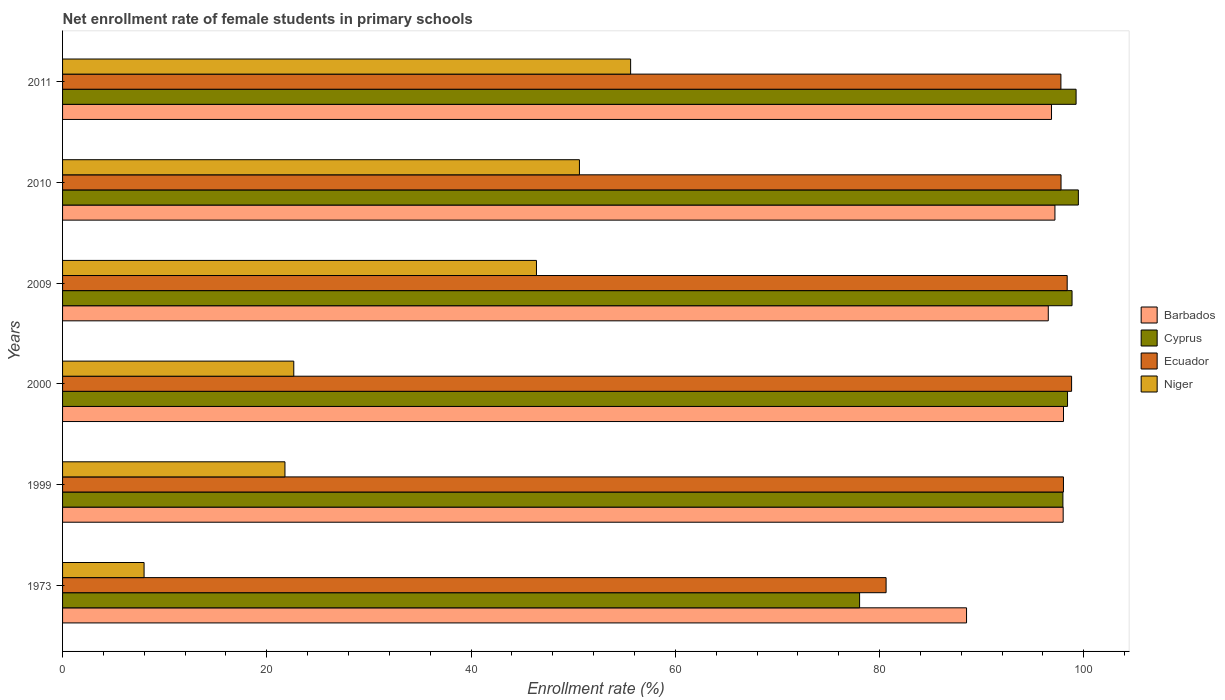How many groups of bars are there?
Keep it short and to the point. 6. Are the number of bars per tick equal to the number of legend labels?
Offer a very short reply. Yes. Are the number of bars on each tick of the Y-axis equal?
Provide a short and direct response. Yes. How many bars are there on the 3rd tick from the bottom?
Provide a succinct answer. 4. What is the label of the 5th group of bars from the top?
Offer a terse response. 1999. What is the net enrollment rate of female students in primary schools in Barbados in 2009?
Your response must be concise. 96.52. Across all years, what is the maximum net enrollment rate of female students in primary schools in Niger?
Your answer should be compact. 55.62. Across all years, what is the minimum net enrollment rate of female students in primary schools in Cyprus?
Your response must be concise. 78.04. In which year was the net enrollment rate of female students in primary schools in Niger maximum?
Make the answer very short. 2011. In which year was the net enrollment rate of female students in primary schools in Niger minimum?
Provide a short and direct response. 1973. What is the total net enrollment rate of female students in primary schools in Ecuador in the graph?
Your answer should be very brief. 571.34. What is the difference between the net enrollment rate of female students in primary schools in Barbados in 1999 and that in 2009?
Offer a very short reply. 1.46. What is the difference between the net enrollment rate of female students in primary schools in Niger in 2000 and the net enrollment rate of female students in primary schools in Ecuador in 1999?
Give a very brief answer. -75.37. What is the average net enrollment rate of female students in primary schools in Cyprus per year?
Make the answer very short. 95.33. In the year 2010, what is the difference between the net enrollment rate of female students in primary schools in Cyprus and net enrollment rate of female students in primary schools in Barbados?
Keep it short and to the point. 2.29. In how many years, is the net enrollment rate of female students in primary schools in Barbados greater than 96 %?
Your response must be concise. 5. What is the ratio of the net enrollment rate of female students in primary schools in Niger in 1999 to that in 2010?
Your answer should be compact. 0.43. What is the difference between the highest and the second highest net enrollment rate of female students in primary schools in Ecuador?
Keep it short and to the point. 0.43. What is the difference between the highest and the lowest net enrollment rate of female students in primary schools in Niger?
Your response must be concise. 47.64. In how many years, is the net enrollment rate of female students in primary schools in Barbados greater than the average net enrollment rate of female students in primary schools in Barbados taken over all years?
Your answer should be compact. 5. Is the sum of the net enrollment rate of female students in primary schools in Cyprus in 1999 and 2011 greater than the maximum net enrollment rate of female students in primary schools in Ecuador across all years?
Your answer should be compact. Yes. Is it the case that in every year, the sum of the net enrollment rate of female students in primary schools in Barbados and net enrollment rate of female students in primary schools in Ecuador is greater than the sum of net enrollment rate of female students in primary schools in Niger and net enrollment rate of female students in primary schools in Cyprus?
Give a very brief answer. No. What does the 2nd bar from the top in 2009 represents?
Your response must be concise. Ecuador. What does the 1st bar from the bottom in 1999 represents?
Your response must be concise. Barbados. How many bars are there?
Keep it short and to the point. 24. How many years are there in the graph?
Your answer should be very brief. 6. What is the difference between two consecutive major ticks on the X-axis?
Your response must be concise. 20. Are the values on the major ticks of X-axis written in scientific E-notation?
Make the answer very short. No. Where does the legend appear in the graph?
Your answer should be very brief. Center right. How many legend labels are there?
Ensure brevity in your answer.  4. What is the title of the graph?
Make the answer very short. Net enrollment rate of female students in primary schools. Does "Lesotho" appear as one of the legend labels in the graph?
Offer a very short reply. No. What is the label or title of the X-axis?
Your answer should be very brief. Enrollment rate (%). What is the Enrollment rate (%) of Barbados in 1973?
Ensure brevity in your answer.  88.52. What is the Enrollment rate (%) of Cyprus in 1973?
Your answer should be compact. 78.04. What is the Enrollment rate (%) in Ecuador in 1973?
Your answer should be compact. 80.64. What is the Enrollment rate (%) of Niger in 1973?
Your answer should be compact. 7.98. What is the Enrollment rate (%) of Barbados in 1999?
Ensure brevity in your answer.  97.98. What is the Enrollment rate (%) of Cyprus in 1999?
Provide a succinct answer. 97.95. What is the Enrollment rate (%) in Ecuador in 1999?
Your response must be concise. 98.01. What is the Enrollment rate (%) of Niger in 1999?
Your answer should be compact. 21.78. What is the Enrollment rate (%) of Barbados in 2000?
Make the answer very short. 98.01. What is the Enrollment rate (%) of Cyprus in 2000?
Offer a very short reply. 98.4. What is the Enrollment rate (%) of Ecuador in 2000?
Your response must be concise. 98.8. What is the Enrollment rate (%) in Niger in 2000?
Your response must be concise. 22.64. What is the Enrollment rate (%) in Barbados in 2009?
Your answer should be compact. 96.52. What is the Enrollment rate (%) of Cyprus in 2009?
Provide a succinct answer. 98.85. What is the Enrollment rate (%) in Ecuador in 2009?
Give a very brief answer. 98.37. What is the Enrollment rate (%) of Niger in 2009?
Your response must be concise. 46.4. What is the Enrollment rate (%) in Barbados in 2010?
Make the answer very short. 97.17. What is the Enrollment rate (%) of Cyprus in 2010?
Offer a terse response. 99.46. What is the Enrollment rate (%) in Ecuador in 2010?
Your response must be concise. 97.77. What is the Enrollment rate (%) of Niger in 2010?
Give a very brief answer. 50.61. What is the Enrollment rate (%) of Barbados in 2011?
Make the answer very short. 96.84. What is the Enrollment rate (%) of Cyprus in 2011?
Offer a terse response. 99.24. What is the Enrollment rate (%) in Ecuador in 2011?
Offer a very short reply. 97.76. What is the Enrollment rate (%) of Niger in 2011?
Offer a terse response. 55.62. Across all years, what is the maximum Enrollment rate (%) of Barbados?
Provide a succinct answer. 98.01. Across all years, what is the maximum Enrollment rate (%) of Cyprus?
Provide a succinct answer. 99.46. Across all years, what is the maximum Enrollment rate (%) in Ecuador?
Offer a very short reply. 98.8. Across all years, what is the maximum Enrollment rate (%) of Niger?
Offer a terse response. 55.62. Across all years, what is the minimum Enrollment rate (%) in Barbados?
Provide a succinct answer. 88.52. Across all years, what is the minimum Enrollment rate (%) of Cyprus?
Provide a succinct answer. 78.04. Across all years, what is the minimum Enrollment rate (%) of Ecuador?
Offer a terse response. 80.64. Across all years, what is the minimum Enrollment rate (%) of Niger?
Provide a succinct answer. 7.98. What is the total Enrollment rate (%) in Barbados in the graph?
Give a very brief answer. 575.03. What is the total Enrollment rate (%) in Cyprus in the graph?
Make the answer very short. 571.96. What is the total Enrollment rate (%) of Ecuador in the graph?
Provide a succinct answer. 571.34. What is the total Enrollment rate (%) of Niger in the graph?
Provide a succinct answer. 205.04. What is the difference between the Enrollment rate (%) in Barbados in 1973 and that in 1999?
Provide a succinct answer. -9.46. What is the difference between the Enrollment rate (%) of Cyprus in 1973 and that in 1999?
Offer a very short reply. -19.91. What is the difference between the Enrollment rate (%) of Ecuador in 1973 and that in 1999?
Your answer should be very brief. -17.37. What is the difference between the Enrollment rate (%) in Niger in 1973 and that in 1999?
Your answer should be compact. -13.79. What is the difference between the Enrollment rate (%) of Barbados in 1973 and that in 2000?
Make the answer very short. -9.49. What is the difference between the Enrollment rate (%) in Cyprus in 1973 and that in 2000?
Give a very brief answer. -20.36. What is the difference between the Enrollment rate (%) of Ecuador in 1973 and that in 2000?
Provide a succinct answer. -18.16. What is the difference between the Enrollment rate (%) in Niger in 1973 and that in 2000?
Offer a terse response. -14.66. What is the difference between the Enrollment rate (%) in Barbados in 1973 and that in 2009?
Give a very brief answer. -8. What is the difference between the Enrollment rate (%) in Cyprus in 1973 and that in 2009?
Ensure brevity in your answer.  -20.8. What is the difference between the Enrollment rate (%) in Ecuador in 1973 and that in 2009?
Give a very brief answer. -17.73. What is the difference between the Enrollment rate (%) in Niger in 1973 and that in 2009?
Ensure brevity in your answer.  -38.42. What is the difference between the Enrollment rate (%) in Barbados in 1973 and that in 2010?
Offer a very short reply. -8.66. What is the difference between the Enrollment rate (%) in Cyprus in 1973 and that in 2010?
Provide a short and direct response. -21.42. What is the difference between the Enrollment rate (%) of Ecuador in 1973 and that in 2010?
Your response must be concise. -17.13. What is the difference between the Enrollment rate (%) of Niger in 1973 and that in 2010?
Provide a short and direct response. -42.63. What is the difference between the Enrollment rate (%) of Barbados in 1973 and that in 2011?
Provide a succinct answer. -8.32. What is the difference between the Enrollment rate (%) of Cyprus in 1973 and that in 2011?
Your answer should be compact. -21.2. What is the difference between the Enrollment rate (%) in Ecuador in 1973 and that in 2011?
Your answer should be very brief. -17.12. What is the difference between the Enrollment rate (%) in Niger in 1973 and that in 2011?
Provide a short and direct response. -47.64. What is the difference between the Enrollment rate (%) in Barbados in 1999 and that in 2000?
Provide a short and direct response. -0.03. What is the difference between the Enrollment rate (%) in Cyprus in 1999 and that in 2000?
Offer a terse response. -0.45. What is the difference between the Enrollment rate (%) in Ecuador in 1999 and that in 2000?
Provide a succinct answer. -0.8. What is the difference between the Enrollment rate (%) of Niger in 1999 and that in 2000?
Make the answer very short. -0.86. What is the difference between the Enrollment rate (%) in Barbados in 1999 and that in 2009?
Offer a terse response. 1.46. What is the difference between the Enrollment rate (%) of Cyprus in 1999 and that in 2009?
Your answer should be compact. -0.9. What is the difference between the Enrollment rate (%) in Ecuador in 1999 and that in 2009?
Ensure brevity in your answer.  -0.37. What is the difference between the Enrollment rate (%) of Niger in 1999 and that in 2009?
Your response must be concise. -24.63. What is the difference between the Enrollment rate (%) in Barbados in 1999 and that in 2010?
Provide a short and direct response. 0.81. What is the difference between the Enrollment rate (%) in Cyprus in 1999 and that in 2010?
Your answer should be very brief. -1.51. What is the difference between the Enrollment rate (%) of Ecuador in 1999 and that in 2010?
Your answer should be compact. 0.24. What is the difference between the Enrollment rate (%) in Niger in 1999 and that in 2010?
Make the answer very short. -28.84. What is the difference between the Enrollment rate (%) of Barbados in 1999 and that in 2011?
Offer a very short reply. 1.14. What is the difference between the Enrollment rate (%) of Cyprus in 1999 and that in 2011?
Provide a short and direct response. -1.29. What is the difference between the Enrollment rate (%) of Ecuador in 1999 and that in 2011?
Offer a terse response. 0.25. What is the difference between the Enrollment rate (%) in Niger in 1999 and that in 2011?
Give a very brief answer. -33.85. What is the difference between the Enrollment rate (%) of Barbados in 2000 and that in 2009?
Ensure brevity in your answer.  1.49. What is the difference between the Enrollment rate (%) in Cyprus in 2000 and that in 2009?
Make the answer very short. -0.44. What is the difference between the Enrollment rate (%) in Ecuador in 2000 and that in 2009?
Provide a short and direct response. 0.43. What is the difference between the Enrollment rate (%) in Niger in 2000 and that in 2009?
Provide a short and direct response. -23.76. What is the difference between the Enrollment rate (%) in Barbados in 2000 and that in 2010?
Provide a succinct answer. 0.84. What is the difference between the Enrollment rate (%) in Cyprus in 2000 and that in 2010?
Your response must be concise. -1.06. What is the difference between the Enrollment rate (%) in Ecuador in 2000 and that in 2010?
Provide a succinct answer. 1.03. What is the difference between the Enrollment rate (%) of Niger in 2000 and that in 2010?
Ensure brevity in your answer.  -27.97. What is the difference between the Enrollment rate (%) of Barbados in 2000 and that in 2011?
Provide a short and direct response. 1.17. What is the difference between the Enrollment rate (%) in Cyprus in 2000 and that in 2011?
Your response must be concise. -0.84. What is the difference between the Enrollment rate (%) in Ecuador in 2000 and that in 2011?
Ensure brevity in your answer.  1.05. What is the difference between the Enrollment rate (%) of Niger in 2000 and that in 2011?
Your answer should be very brief. -32.98. What is the difference between the Enrollment rate (%) of Barbados in 2009 and that in 2010?
Your response must be concise. -0.65. What is the difference between the Enrollment rate (%) in Cyprus in 2009 and that in 2010?
Give a very brief answer. -0.62. What is the difference between the Enrollment rate (%) in Ecuador in 2009 and that in 2010?
Give a very brief answer. 0.6. What is the difference between the Enrollment rate (%) of Niger in 2009 and that in 2010?
Make the answer very short. -4.21. What is the difference between the Enrollment rate (%) in Barbados in 2009 and that in 2011?
Make the answer very short. -0.32. What is the difference between the Enrollment rate (%) in Cyprus in 2009 and that in 2011?
Your answer should be very brief. -0.4. What is the difference between the Enrollment rate (%) in Ecuador in 2009 and that in 2011?
Keep it short and to the point. 0.62. What is the difference between the Enrollment rate (%) in Niger in 2009 and that in 2011?
Make the answer very short. -9.22. What is the difference between the Enrollment rate (%) in Barbados in 2010 and that in 2011?
Offer a very short reply. 0.34. What is the difference between the Enrollment rate (%) in Cyprus in 2010 and that in 2011?
Provide a short and direct response. 0.22. What is the difference between the Enrollment rate (%) in Ecuador in 2010 and that in 2011?
Keep it short and to the point. 0.01. What is the difference between the Enrollment rate (%) in Niger in 2010 and that in 2011?
Your answer should be very brief. -5.01. What is the difference between the Enrollment rate (%) of Barbados in 1973 and the Enrollment rate (%) of Cyprus in 1999?
Offer a very short reply. -9.44. What is the difference between the Enrollment rate (%) of Barbados in 1973 and the Enrollment rate (%) of Ecuador in 1999?
Offer a terse response. -9.49. What is the difference between the Enrollment rate (%) of Barbados in 1973 and the Enrollment rate (%) of Niger in 1999?
Make the answer very short. 66.74. What is the difference between the Enrollment rate (%) in Cyprus in 1973 and the Enrollment rate (%) in Ecuador in 1999?
Provide a succinct answer. -19.96. What is the difference between the Enrollment rate (%) of Cyprus in 1973 and the Enrollment rate (%) of Niger in 1999?
Keep it short and to the point. 56.27. What is the difference between the Enrollment rate (%) in Ecuador in 1973 and the Enrollment rate (%) in Niger in 1999?
Offer a terse response. 58.86. What is the difference between the Enrollment rate (%) in Barbados in 1973 and the Enrollment rate (%) in Cyprus in 2000?
Your answer should be very brief. -9.89. What is the difference between the Enrollment rate (%) of Barbados in 1973 and the Enrollment rate (%) of Ecuador in 2000?
Your response must be concise. -10.29. What is the difference between the Enrollment rate (%) in Barbados in 1973 and the Enrollment rate (%) in Niger in 2000?
Your answer should be very brief. 65.88. What is the difference between the Enrollment rate (%) in Cyprus in 1973 and the Enrollment rate (%) in Ecuador in 2000?
Offer a terse response. -20.76. What is the difference between the Enrollment rate (%) of Cyprus in 1973 and the Enrollment rate (%) of Niger in 2000?
Offer a terse response. 55.4. What is the difference between the Enrollment rate (%) of Ecuador in 1973 and the Enrollment rate (%) of Niger in 2000?
Offer a terse response. 58. What is the difference between the Enrollment rate (%) of Barbados in 1973 and the Enrollment rate (%) of Cyprus in 2009?
Offer a terse response. -10.33. What is the difference between the Enrollment rate (%) of Barbados in 1973 and the Enrollment rate (%) of Ecuador in 2009?
Ensure brevity in your answer.  -9.86. What is the difference between the Enrollment rate (%) of Barbados in 1973 and the Enrollment rate (%) of Niger in 2009?
Offer a terse response. 42.11. What is the difference between the Enrollment rate (%) in Cyprus in 1973 and the Enrollment rate (%) in Ecuador in 2009?
Ensure brevity in your answer.  -20.33. What is the difference between the Enrollment rate (%) of Cyprus in 1973 and the Enrollment rate (%) of Niger in 2009?
Provide a succinct answer. 31.64. What is the difference between the Enrollment rate (%) in Ecuador in 1973 and the Enrollment rate (%) in Niger in 2009?
Your answer should be very brief. 34.23. What is the difference between the Enrollment rate (%) of Barbados in 1973 and the Enrollment rate (%) of Cyprus in 2010?
Give a very brief answer. -10.95. What is the difference between the Enrollment rate (%) in Barbados in 1973 and the Enrollment rate (%) in Ecuador in 2010?
Offer a terse response. -9.25. What is the difference between the Enrollment rate (%) in Barbados in 1973 and the Enrollment rate (%) in Niger in 2010?
Provide a succinct answer. 37.91. What is the difference between the Enrollment rate (%) of Cyprus in 1973 and the Enrollment rate (%) of Ecuador in 2010?
Offer a terse response. -19.72. What is the difference between the Enrollment rate (%) in Cyprus in 1973 and the Enrollment rate (%) in Niger in 2010?
Give a very brief answer. 27.43. What is the difference between the Enrollment rate (%) of Ecuador in 1973 and the Enrollment rate (%) of Niger in 2010?
Keep it short and to the point. 30.03. What is the difference between the Enrollment rate (%) of Barbados in 1973 and the Enrollment rate (%) of Cyprus in 2011?
Provide a succinct answer. -10.73. What is the difference between the Enrollment rate (%) in Barbados in 1973 and the Enrollment rate (%) in Ecuador in 2011?
Ensure brevity in your answer.  -9.24. What is the difference between the Enrollment rate (%) in Barbados in 1973 and the Enrollment rate (%) in Niger in 2011?
Ensure brevity in your answer.  32.89. What is the difference between the Enrollment rate (%) of Cyprus in 1973 and the Enrollment rate (%) of Ecuador in 2011?
Provide a short and direct response. -19.71. What is the difference between the Enrollment rate (%) in Cyprus in 1973 and the Enrollment rate (%) in Niger in 2011?
Offer a very short reply. 22.42. What is the difference between the Enrollment rate (%) in Ecuador in 1973 and the Enrollment rate (%) in Niger in 2011?
Ensure brevity in your answer.  25.01. What is the difference between the Enrollment rate (%) of Barbados in 1999 and the Enrollment rate (%) of Cyprus in 2000?
Offer a terse response. -0.43. What is the difference between the Enrollment rate (%) of Barbados in 1999 and the Enrollment rate (%) of Ecuador in 2000?
Ensure brevity in your answer.  -0.82. What is the difference between the Enrollment rate (%) in Barbados in 1999 and the Enrollment rate (%) in Niger in 2000?
Your answer should be very brief. 75.34. What is the difference between the Enrollment rate (%) in Cyprus in 1999 and the Enrollment rate (%) in Ecuador in 2000?
Provide a succinct answer. -0.85. What is the difference between the Enrollment rate (%) in Cyprus in 1999 and the Enrollment rate (%) in Niger in 2000?
Keep it short and to the point. 75.31. What is the difference between the Enrollment rate (%) of Ecuador in 1999 and the Enrollment rate (%) of Niger in 2000?
Offer a very short reply. 75.37. What is the difference between the Enrollment rate (%) of Barbados in 1999 and the Enrollment rate (%) of Cyprus in 2009?
Give a very brief answer. -0.87. What is the difference between the Enrollment rate (%) in Barbados in 1999 and the Enrollment rate (%) in Ecuador in 2009?
Provide a short and direct response. -0.39. What is the difference between the Enrollment rate (%) of Barbados in 1999 and the Enrollment rate (%) of Niger in 2009?
Your answer should be very brief. 51.57. What is the difference between the Enrollment rate (%) in Cyprus in 1999 and the Enrollment rate (%) in Ecuador in 2009?
Provide a short and direct response. -0.42. What is the difference between the Enrollment rate (%) of Cyprus in 1999 and the Enrollment rate (%) of Niger in 2009?
Your response must be concise. 51.55. What is the difference between the Enrollment rate (%) in Ecuador in 1999 and the Enrollment rate (%) in Niger in 2009?
Your answer should be compact. 51.6. What is the difference between the Enrollment rate (%) of Barbados in 1999 and the Enrollment rate (%) of Cyprus in 2010?
Make the answer very short. -1.49. What is the difference between the Enrollment rate (%) of Barbados in 1999 and the Enrollment rate (%) of Ecuador in 2010?
Your answer should be compact. 0.21. What is the difference between the Enrollment rate (%) of Barbados in 1999 and the Enrollment rate (%) of Niger in 2010?
Offer a very short reply. 47.37. What is the difference between the Enrollment rate (%) in Cyprus in 1999 and the Enrollment rate (%) in Ecuador in 2010?
Make the answer very short. 0.18. What is the difference between the Enrollment rate (%) in Cyprus in 1999 and the Enrollment rate (%) in Niger in 2010?
Your answer should be very brief. 47.34. What is the difference between the Enrollment rate (%) of Ecuador in 1999 and the Enrollment rate (%) of Niger in 2010?
Ensure brevity in your answer.  47.4. What is the difference between the Enrollment rate (%) in Barbados in 1999 and the Enrollment rate (%) in Cyprus in 2011?
Your response must be concise. -1.26. What is the difference between the Enrollment rate (%) of Barbados in 1999 and the Enrollment rate (%) of Ecuador in 2011?
Provide a short and direct response. 0.22. What is the difference between the Enrollment rate (%) in Barbados in 1999 and the Enrollment rate (%) in Niger in 2011?
Your response must be concise. 42.35. What is the difference between the Enrollment rate (%) of Cyprus in 1999 and the Enrollment rate (%) of Ecuador in 2011?
Ensure brevity in your answer.  0.2. What is the difference between the Enrollment rate (%) of Cyprus in 1999 and the Enrollment rate (%) of Niger in 2011?
Offer a terse response. 42.33. What is the difference between the Enrollment rate (%) of Ecuador in 1999 and the Enrollment rate (%) of Niger in 2011?
Ensure brevity in your answer.  42.38. What is the difference between the Enrollment rate (%) of Barbados in 2000 and the Enrollment rate (%) of Cyprus in 2009?
Your answer should be very brief. -0.84. What is the difference between the Enrollment rate (%) in Barbados in 2000 and the Enrollment rate (%) in Ecuador in 2009?
Your answer should be very brief. -0.36. What is the difference between the Enrollment rate (%) in Barbados in 2000 and the Enrollment rate (%) in Niger in 2009?
Ensure brevity in your answer.  51.61. What is the difference between the Enrollment rate (%) in Cyprus in 2000 and the Enrollment rate (%) in Ecuador in 2009?
Provide a short and direct response. 0.03. What is the difference between the Enrollment rate (%) of Cyprus in 2000 and the Enrollment rate (%) of Niger in 2009?
Ensure brevity in your answer.  52. What is the difference between the Enrollment rate (%) in Ecuador in 2000 and the Enrollment rate (%) in Niger in 2009?
Offer a very short reply. 52.4. What is the difference between the Enrollment rate (%) of Barbados in 2000 and the Enrollment rate (%) of Cyprus in 2010?
Keep it short and to the point. -1.45. What is the difference between the Enrollment rate (%) of Barbados in 2000 and the Enrollment rate (%) of Ecuador in 2010?
Provide a succinct answer. 0.24. What is the difference between the Enrollment rate (%) in Barbados in 2000 and the Enrollment rate (%) in Niger in 2010?
Give a very brief answer. 47.4. What is the difference between the Enrollment rate (%) of Cyprus in 2000 and the Enrollment rate (%) of Ecuador in 2010?
Keep it short and to the point. 0.64. What is the difference between the Enrollment rate (%) of Cyprus in 2000 and the Enrollment rate (%) of Niger in 2010?
Your response must be concise. 47.79. What is the difference between the Enrollment rate (%) of Ecuador in 2000 and the Enrollment rate (%) of Niger in 2010?
Give a very brief answer. 48.19. What is the difference between the Enrollment rate (%) in Barbados in 2000 and the Enrollment rate (%) in Cyprus in 2011?
Give a very brief answer. -1.23. What is the difference between the Enrollment rate (%) of Barbados in 2000 and the Enrollment rate (%) of Ecuador in 2011?
Offer a very short reply. 0.25. What is the difference between the Enrollment rate (%) of Barbados in 2000 and the Enrollment rate (%) of Niger in 2011?
Make the answer very short. 42.39. What is the difference between the Enrollment rate (%) in Cyprus in 2000 and the Enrollment rate (%) in Ecuador in 2011?
Your answer should be very brief. 0.65. What is the difference between the Enrollment rate (%) of Cyprus in 2000 and the Enrollment rate (%) of Niger in 2011?
Your response must be concise. 42.78. What is the difference between the Enrollment rate (%) in Ecuador in 2000 and the Enrollment rate (%) in Niger in 2011?
Keep it short and to the point. 43.18. What is the difference between the Enrollment rate (%) of Barbados in 2009 and the Enrollment rate (%) of Cyprus in 2010?
Keep it short and to the point. -2.95. What is the difference between the Enrollment rate (%) in Barbados in 2009 and the Enrollment rate (%) in Ecuador in 2010?
Your response must be concise. -1.25. What is the difference between the Enrollment rate (%) in Barbados in 2009 and the Enrollment rate (%) in Niger in 2010?
Your answer should be very brief. 45.91. What is the difference between the Enrollment rate (%) of Cyprus in 2009 and the Enrollment rate (%) of Ecuador in 2010?
Provide a succinct answer. 1.08. What is the difference between the Enrollment rate (%) of Cyprus in 2009 and the Enrollment rate (%) of Niger in 2010?
Provide a short and direct response. 48.24. What is the difference between the Enrollment rate (%) of Ecuador in 2009 and the Enrollment rate (%) of Niger in 2010?
Your answer should be very brief. 47.76. What is the difference between the Enrollment rate (%) of Barbados in 2009 and the Enrollment rate (%) of Cyprus in 2011?
Offer a very short reply. -2.72. What is the difference between the Enrollment rate (%) in Barbados in 2009 and the Enrollment rate (%) in Ecuador in 2011?
Your response must be concise. -1.24. What is the difference between the Enrollment rate (%) in Barbados in 2009 and the Enrollment rate (%) in Niger in 2011?
Your answer should be very brief. 40.9. What is the difference between the Enrollment rate (%) of Cyprus in 2009 and the Enrollment rate (%) of Ecuador in 2011?
Provide a succinct answer. 1.09. What is the difference between the Enrollment rate (%) in Cyprus in 2009 and the Enrollment rate (%) in Niger in 2011?
Give a very brief answer. 43.22. What is the difference between the Enrollment rate (%) in Ecuador in 2009 and the Enrollment rate (%) in Niger in 2011?
Provide a short and direct response. 42.75. What is the difference between the Enrollment rate (%) in Barbados in 2010 and the Enrollment rate (%) in Cyprus in 2011?
Keep it short and to the point. -2.07. What is the difference between the Enrollment rate (%) in Barbados in 2010 and the Enrollment rate (%) in Ecuador in 2011?
Offer a terse response. -0.58. What is the difference between the Enrollment rate (%) in Barbados in 2010 and the Enrollment rate (%) in Niger in 2011?
Provide a short and direct response. 41.55. What is the difference between the Enrollment rate (%) of Cyprus in 2010 and the Enrollment rate (%) of Ecuador in 2011?
Ensure brevity in your answer.  1.71. What is the difference between the Enrollment rate (%) in Cyprus in 2010 and the Enrollment rate (%) in Niger in 2011?
Your response must be concise. 43.84. What is the difference between the Enrollment rate (%) in Ecuador in 2010 and the Enrollment rate (%) in Niger in 2011?
Make the answer very short. 42.14. What is the average Enrollment rate (%) of Barbados per year?
Give a very brief answer. 95.84. What is the average Enrollment rate (%) in Cyprus per year?
Ensure brevity in your answer.  95.33. What is the average Enrollment rate (%) in Ecuador per year?
Your response must be concise. 95.22. What is the average Enrollment rate (%) in Niger per year?
Make the answer very short. 34.17. In the year 1973, what is the difference between the Enrollment rate (%) in Barbados and Enrollment rate (%) in Cyprus?
Give a very brief answer. 10.47. In the year 1973, what is the difference between the Enrollment rate (%) in Barbados and Enrollment rate (%) in Ecuador?
Provide a succinct answer. 7.88. In the year 1973, what is the difference between the Enrollment rate (%) in Barbados and Enrollment rate (%) in Niger?
Your response must be concise. 80.53. In the year 1973, what is the difference between the Enrollment rate (%) in Cyprus and Enrollment rate (%) in Ecuador?
Make the answer very short. -2.59. In the year 1973, what is the difference between the Enrollment rate (%) in Cyprus and Enrollment rate (%) in Niger?
Your response must be concise. 70.06. In the year 1973, what is the difference between the Enrollment rate (%) of Ecuador and Enrollment rate (%) of Niger?
Provide a succinct answer. 72.66. In the year 1999, what is the difference between the Enrollment rate (%) of Barbados and Enrollment rate (%) of Cyprus?
Offer a terse response. 0.03. In the year 1999, what is the difference between the Enrollment rate (%) of Barbados and Enrollment rate (%) of Ecuador?
Provide a succinct answer. -0.03. In the year 1999, what is the difference between the Enrollment rate (%) in Barbados and Enrollment rate (%) in Niger?
Make the answer very short. 76.2. In the year 1999, what is the difference between the Enrollment rate (%) in Cyprus and Enrollment rate (%) in Ecuador?
Your response must be concise. -0.05. In the year 1999, what is the difference between the Enrollment rate (%) of Cyprus and Enrollment rate (%) of Niger?
Give a very brief answer. 76.18. In the year 1999, what is the difference between the Enrollment rate (%) of Ecuador and Enrollment rate (%) of Niger?
Provide a short and direct response. 76.23. In the year 2000, what is the difference between the Enrollment rate (%) of Barbados and Enrollment rate (%) of Cyprus?
Provide a succinct answer. -0.4. In the year 2000, what is the difference between the Enrollment rate (%) in Barbados and Enrollment rate (%) in Ecuador?
Give a very brief answer. -0.79. In the year 2000, what is the difference between the Enrollment rate (%) in Barbados and Enrollment rate (%) in Niger?
Offer a very short reply. 75.37. In the year 2000, what is the difference between the Enrollment rate (%) in Cyprus and Enrollment rate (%) in Ecuador?
Provide a succinct answer. -0.4. In the year 2000, what is the difference between the Enrollment rate (%) of Cyprus and Enrollment rate (%) of Niger?
Your response must be concise. 75.77. In the year 2000, what is the difference between the Enrollment rate (%) in Ecuador and Enrollment rate (%) in Niger?
Provide a short and direct response. 76.16. In the year 2009, what is the difference between the Enrollment rate (%) of Barbados and Enrollment rate (%) of Cyprus?
Give a very brief answer. -2.33. In the year 2009, what is the difference between the Enrollment rate (%) of Barbados and Enrollment rate (%) of Ecuador?
Ensure brevity in your answer.  -1.85. In the year 2009, what is the difference between the Enrollment rate (%) in Barbados and Enrollment rate (%) in Niger?
Your answer should be very brief. 50.12. In the year 2009, what is the difference between the Enrollment rate (%) in Cyprus and Enrollment rate (%) in Ecuador?
Make the answer very short. 0.48. In the year 2009, what is the difference between the Enrollment rate (%) of Cyprus and Enrollment rate (%) of Niger?
Your answer should be compact. 52.44. In the year 2009, what is the difference between the Enrollment rate (%) of Ecuador and Enrollment rate (%) of Niger?
Make the answer very short. 51.97. In the year 2010, what is the difference between the Enrollment rate (%) of Barbados and Enrollment rate (%) of Cyprus?
Offer a terse response. -2.29. In the year 2010, what is the difference between the Enrollment rate (%) of Barbados and Enrollment rate (%) of Ecuador?
Your answer should be very brief. -0.6. In the year 2010, what is the difference between the Enrollment rate (%) of Barbados and Enrollment rate (%) of Niger?
Your response must be concise. 46.56. In the year 2010, what is the difference between the Enrollment rate (%) of Cyprus and Enrollment rate (%) of Ecuador?
Provide a succinct answer. 1.7. In the year 2010, what is the difference between the Enrollment rate (%) of Cyprus and Enrollment rate (%) of Niger?
Make the answer very short. 48.85. In the year 2010, what is the difference between the Enrollment rate (%) of Ecuador and Enrollment rate (%) of Niger?
Provide a succinct answer. 47.16. In the year 2011, what is the difference between the Enrollment rate (%) in Barbados and Enrollment rate (%) in Cyprus?
Provide a short and direct response. -2.41. In the year 2011, what is the difference between the Enrollment rate (%) of Barbados and Enrollment rate (%) of Ecuador?
Ensure brevity in your answer.  -0.92. In the year 2011, what is the difference between the Enrollment rate (%) of Barbados and Enrollment rate (%) of Niger?
Your answer should be compact. 41.21. In the year 2011, what is the difference between the Enrollment rate (%) of Cyprus and Enrollment rate (%) of Ecuador?
Provide a short and direct response. 1.49. In the year 2011, what is the difference between the Enrollment rate (%) of Cyprus and Enrollment rate (%) of Niger?
Your answer should be very brief. 43.62. In the year 2011, what is the difference between the Enrollment rate (%) of Ecuador and Enrollment rate (%) of Niger?
Your response must be concise. 42.13. What is the ratio of the Enrollment rate (%) of Barbados in 1973 to that in 1999?
Provide a succinct answer. 0.9. What is the ratio of the Enrollment rate (%) of Cyprus in 1973 to that in 1999?
Provide a succinct answer. 0.8. What is the ratio of the Enrollment rate (%) of Ecuador in 1973 to that in 1999?
Give a very brief answer. 0.82. What is the ratio of the Enrollment rate (%) of Niger in 1973 to that in 1999?
Your response must be concise. 0.37. What is the ratio of the Enrollment rate (%) of Barbados in 1973 to that in 2000?
Your response must be concise. 0.9. What is the ratio of the Enrollment rate (%) of Cyprus in 1973 to that in 2000?
Your answer should be compact. 0.79. What is the ratio of the Enrollment rate (%) of Ecuador in 1973 to that in 2000?
Offer a very short reply. 0.82. What is the ratio of the Enrollment rate (%) of Niger in 1973 to that in 2000?
Give a very brief answer. 0.35. What is the ratio of the Enrollment rate (%) in Barbados in 1973 to that in 2009?
Provide a succinct answer. 0.92. What is the ratio of the Enrollment rate (%) in Cyprus in 1973 to that in 2009?
Offer a very short reply. 0.79. What is the ratio of the Enrollment rate (%) in Ecuador in 1973 to that in 2009?
Provide a succinct answer. 0.82. What is the ratio of the Enrollment rate (%) in Niger in 1973 to that in 2009?
Your answer should be very brief. 0.17. What is the ratio of the Enrollment rate (%) in Barbados in 1973 to that in 2010?
Offer a very short reply. 0.91. What is the ratio of the Enrollment rate (%) in Cyprus in 1973 to that in 2010?
Provide a succinct answer. 0.78. What is the ratio of the Enrollment rate (%) in Ecuador in 1973 to that in 2010?
Offer a terse response. 0.82. What is the ratio of the Enrollment rate (%) of Niger in 1973 to that in 2010?
Provide a succinct answer. 0.16. What is the ratio of the Enrollment rate (%) of Barbados in 1973 to that in 2011?
Your answer should be compact. 0.91. What is the ratio of the Enrollment rate (%) of Cyprus in 1973 to that in 2011?
Offer a very short reply. 0.79. What is the ratio of the Enrollment rate (%) in Ecuador in 1973 to that in 2011?
Give a very brief answer. 0.82. What is the ratio of the Enrollment rate (%) of Niger in 1973 to that in 2011?
Provide a succinct answer. 0.14. What is the ratio of the Enrollment rate (%) of Ecuador in 1999 to that in 2000?
Your answer should be very brief. 0.99. What is the ratio of the Enrollment rate (%) of Niger in 1999 to that in 2000?
Offer a very short reply. 0.96. What is the ratio of the Enrollment rate (%) in Barbados in 1999 to that in 2009?
Your response must be concise. 1.02. What is the ratio of the Enrollment rate (%) in Cyprus in 1999 to that in 2009?
Provide a succinct answer. 0.99. What is the ratio of the Enrollment rate (%) in Niger in 1999 to that in 2009?
Make the answer very short. 0.47. What is the ratio of the Enrollment rate (%) of Barbados in 1999 to that in 2010?
Your answer should be very brief. 1.01. What is the ratio of the Enrollment rate (%) of Cyprus in 1999 to that in 2010?
Your answer should be compact. 0.98. What is the ratio of the Enrollment rate (%) in Niger in 1999 to that in 2010?
Provide a succinct answer. 0.43. What is the ratio of the Enrollment rate (%) in Barbados in 1999 to that in 2011?
Your answer should be very brief. 1.01. What is the ratio of the Enrollment rate (%) in Niger in 1999 to that in 2011?
Your response must be concise. 0.39. What is the ratio of the Enrollment rate (%) in Barbados in 2000 to that in 2009?
Keep it short and to the point. 1.02. What is the ratio of the Enrollment rate (%) of Cyprus in 2000 to that in 2009?
Offer a very short reply. 1. What is the ratio of the Enrollment rate (%) in Ecuador in 2000 to that in 2009?
Ensure brevity in your answer.  1. What is the ratio of the Enrollment rate (%) of Niger in 2000 to that in 2009?
Your answer should be very brief. 0.49. What is the ratio of the Enrollment rate (%) in Barbados in 2000 to that in 2010?
Provide a short and direct response. 1.01. What is the ratio of the Enrollment rate (%) in Cyprus in 2000 to that in 2010?
Offer a very short reply. 0.99. What is the ratio of the Enrollment rate (%) of Ecuador in 2000 to that in 2010?
Provide a short and direct response. 1.01. What is the ratio of the Enrollment rate (%) in Niger in 2000 to that in 2010?
Offer a terse response. 0.45. What is the ratio of the Enrollment rate (%) in Barbados in 2000 to that in 2011?
Keep it short and to the point. 1.01. What is the ratio of the Enrollment rate (%) in Cyprus in 2000 to that in 2011?
Make the answer very short. 0.99. What is the ratio of the Enrollment rate (%) of Ecuador in 2000 to that in 2011?
Offer a terse response. 1.01. What is the ratio of the Enrollment rate (%) of Niger in 2000 to that in 2011?
Your answer should be very brief. 0.41. What is the ratio of the Enrollment rate (%) of Niger in 2009 to that in 2010?
Offer a terse response. 0.92. What is the ratio of the Enrollment rate (%) of Barbados in 2009 to that in 2011?
Give a very brief answer. 1. What is the ratio of the Enrollment rate (%) in Ecuador in 2009 to that in 2011?
Offer a very short reply. 1.01. What is the ratio of the Enrollment rate (%) in Niger in 2009 to that in 2011?
Provide a succinct answer. 0.83. What is the ratio of the Enrollment rate (%) of Niger in 2010 to that in 2011?
Offer a terse response. 0.91. What is the difference between the highest and the second highest Enrollment rate (%) of Barbados?
Your response must be concise. 0.03. What is the difference between the highest and the second highest Enrollment rate (%) of Cyprus?
Your response must be concise. 0.22. What is the difference between the highest and the second highest Enrollment rate (%) in Ecuador?
Offer a terse response. 0.43. What is the difference between the highest and the second highest Enrollment rate (%) in Niger?
Your response must be concise. 5.01. What is the difference between the highest and the lowest Enrollment rate (%) in Barbados?
Keep it short and to the point. 9.49. What is the difference between the highest and the lowest Enrollment rate (%) of Cyprus?
Your response must be concise. 21.42. What is the difference between the highest and the lowest Enrollment rate (%) of Ecuador?
Your response must be concise. 18.16. What is the difference between the highest and the lowest Enrollment rate (%) of Niger?
Make the answer very short. 47.64. 